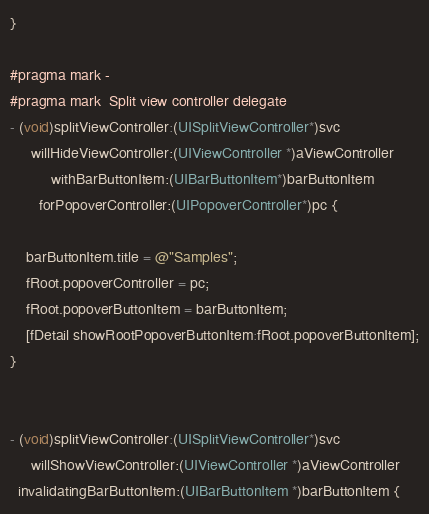<code> <loc_0><loc_0><loc_500><loc_500><_ObjectiveC_>}

#pragma mark -
#pragma mark  Split view controller delegate
- (void)splitViewController:(UISplitViewController*)svc 
     willHideViewController:(UIViewController *)aViewController 
          withBarButtonItem:(UIBarButtonItem*)barButtonItem 
       forPopoverController:(UIPopoverController*)pc {
    
    barButtonItem.title = @"Samples";
    fRoot.popoverController = pc;
    fRoot.popoverButtonItem = barButtonItem;
    [fDetail showRootPopoverButtonItem:fRoot.popoverButtonItem];
}


- (void)splitViewController:(UISplitViewController*)svc 
     willShowViewController:(UIViewController *)aViewController 
  invalidatingBarButtonItem:(UIBarButtonItem *)barButtonItem {</code> 